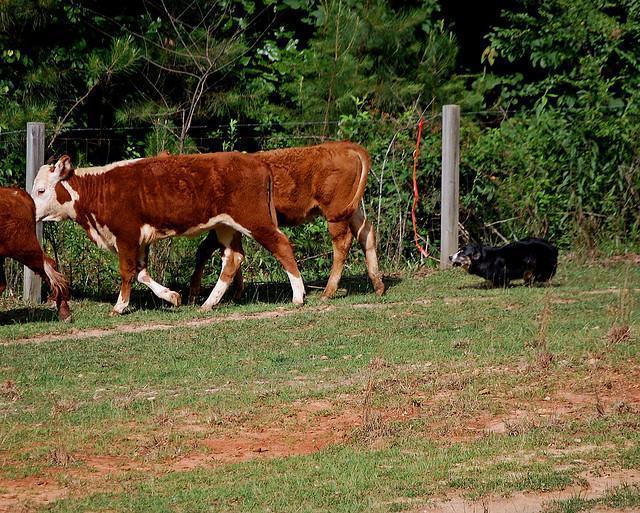How many cows do you see?
Give a very brief answer. 3. How many fence posts are visible?
Give a very brief answer. 2. How many cows can you see?
Give a very brief answer. 3. 